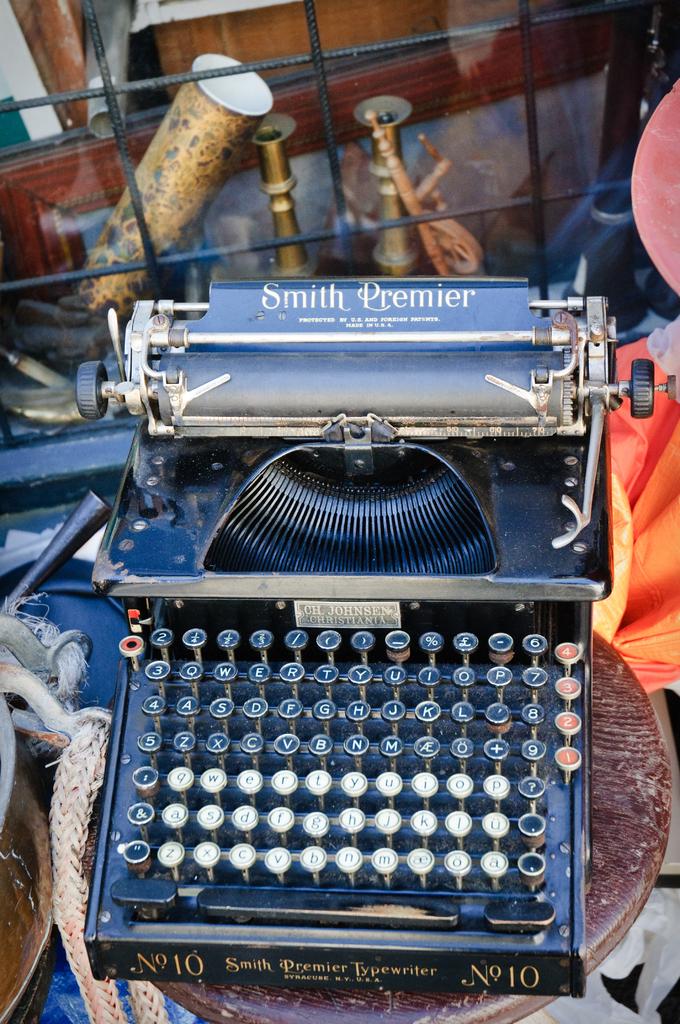What type of typewriter is this?
Offer a terse response. Smith premier. 